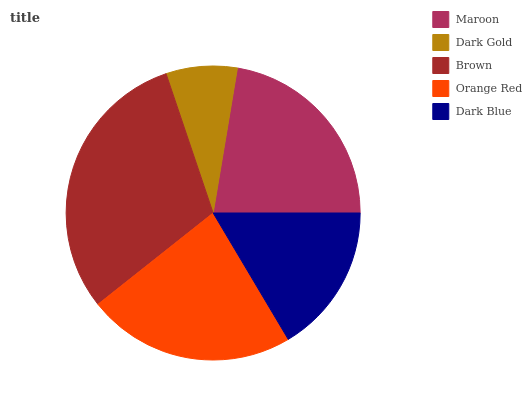Is Dark Gold the minimum?
Answer yes or no. Yes. Is Brown the maximum?
Answer yes or no. Yes. Is Brown the minimum?
Answer yes or no. No. Is Dark Gold the maximum?
Answer yes or no. No. Is Brown greater than Dark Gold?
Answer yes or no. Yes. Is Dark Gold less than Brown?
Answer yes or no. Yes. Is Dark Gold greater than Brown?
Answer yes or no. No. Is Brown less than Dark Gold?
Answer yes or no. No. Is Maroon the high median?
Answer yes or no. Yes. Is Maroon the low median?
Answer yes or no. Yes. Is Brown the high median?
Answer yes or no. No. Is Dark Blue the low median?
Answer yes or no. No. 